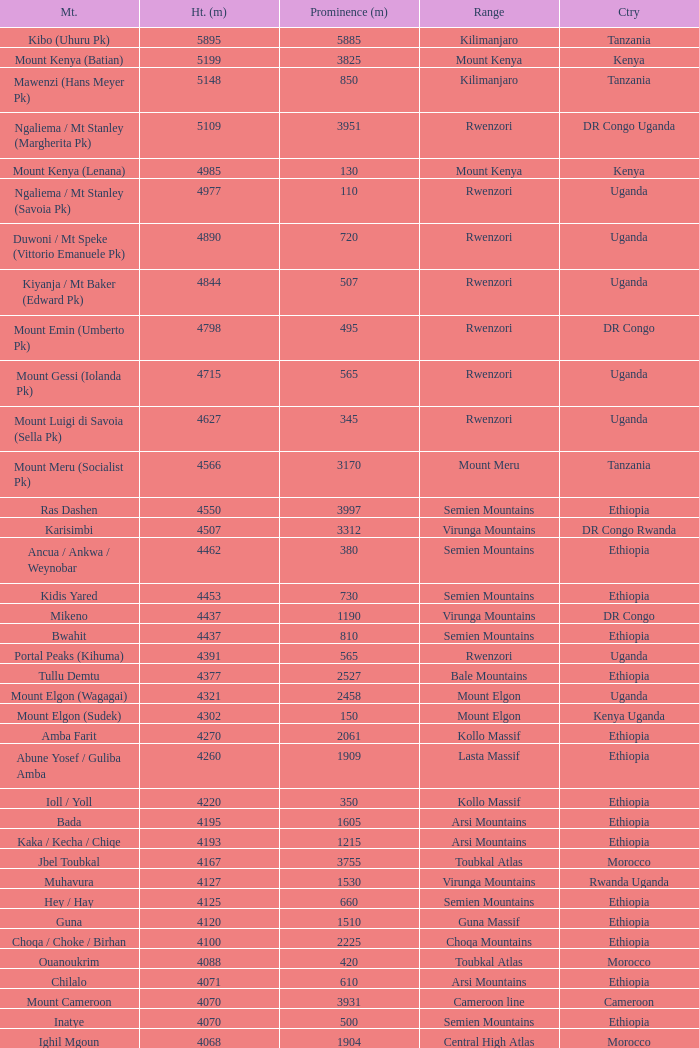Which Country has a Prominence (m) smaller than 1540, and a Height (m) smaller than 3530, and a Range of virunga mountains, and a Mountain of nyiragongo? DR Congo. 